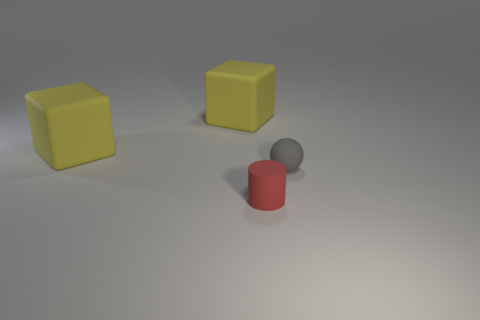What number of objects are either rubber cubes or tiny cyan shiny balls?
Give a very brief answer. 2. There is a tiny thing that is left of the gray ball; what shape is it?
Provide a succinct answer. Cylinder. Is the number of blocks in front of the rubber ball the same as the number of small balls to the right of the red cylinder?
Your response must be concise. No. What number of objects are matte objects or small things that are to the left of the gray rubber sphere?
Offer a terse response. 4. Is there a tiny red object that is right of the small matte object on the right side of the small red cylinder?
Your response must be concise. No. What color is the rubber cylinder?
Your answer should be very brief. Red. There is a matte thing in front of the gray rubber thing; is its size the same as the small gray object?
Offer a terse response. Yes. Is the number of objects on the right side of the tiny red matte cylinder greater than the number of tiny brown rubber cylinders?
Provide a short and direct response. Yes. What size is the cylinder?
Provide a succinct answer. Small. Is the number of small cylinders left of the small red cylinder greater than the number of small red objects that are in front of the tiny gray matte sphere?
Make the answer very short. No. 